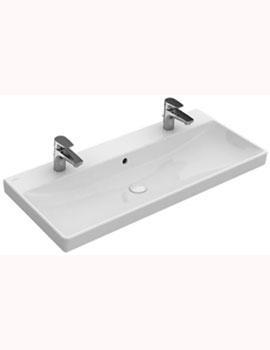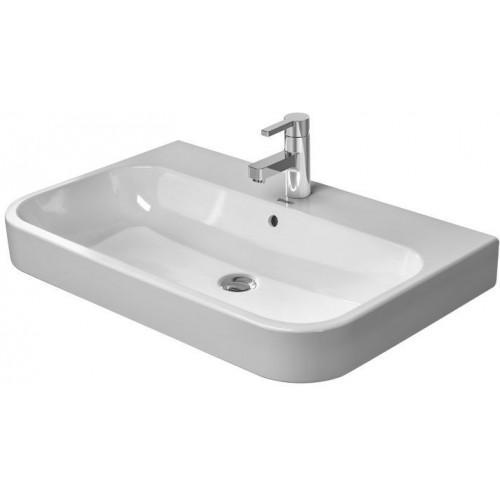The first image is the image on the left, the second image is the image on the right. For the images shown, is this caption "None of the faucets are the rotating kind." true? Answer yes or no. Yes. The first image is the image on the left, the second image is the image on the right. For the images shown, is this caption "There are two drains visible." true? Answer yes or no. Yes. 